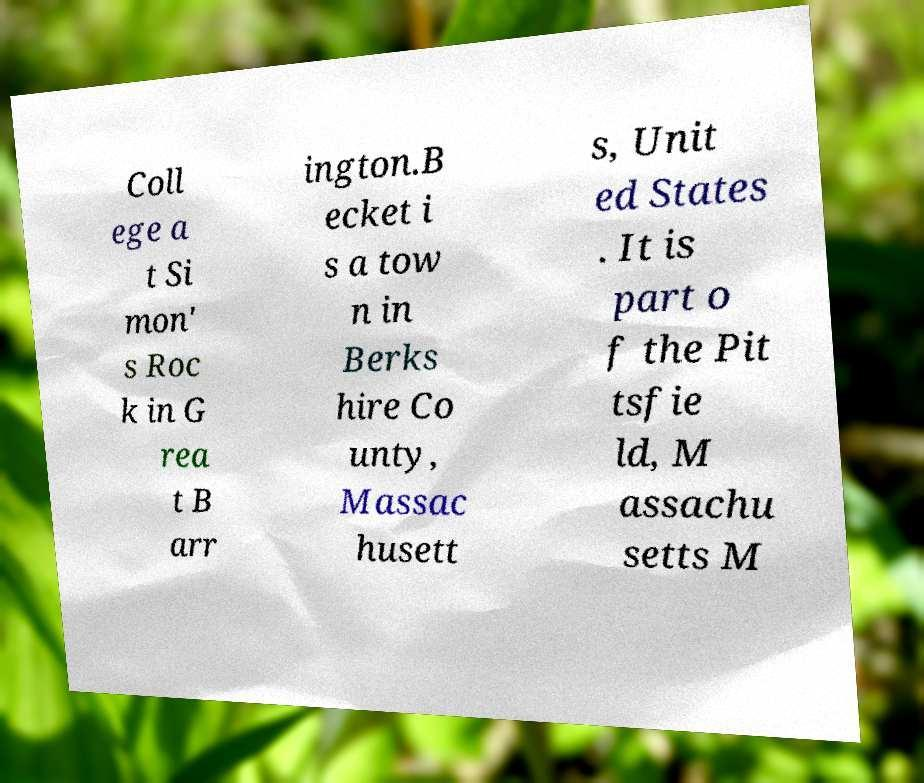For documentation purposes, I need the text within this image transcribed. Could you provide that? Coll ege a t Si mon' s Roc k in G rea t B arr ington.B ecket i s a tow n in Berks hire Co unty, Massac husett s, Unit ed States . It is part o f the Pit tsfie ld, M assachu setts M 